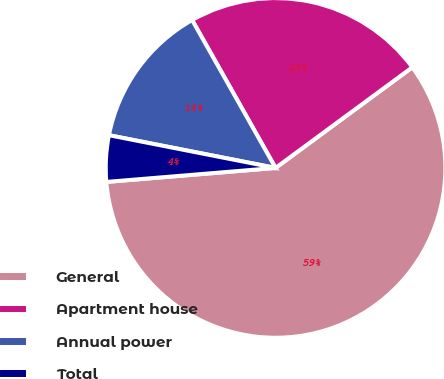Convert chart. <chart><loc_0><loc_0><loc_500><loc_500><pie_chart><fcel>General<fcel>Apartment house<fcel>Annual power<fcel>Total<nl><fcel>58.79%<fcel>23.08%<fcel>13.74%<fcel>4.4%<nl></chart> 